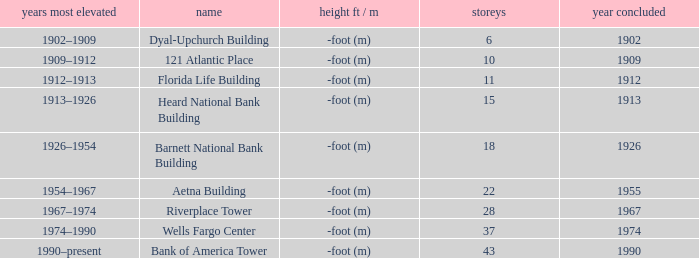What was the name of the building with 10 floors? 121 Atlantic Place. 